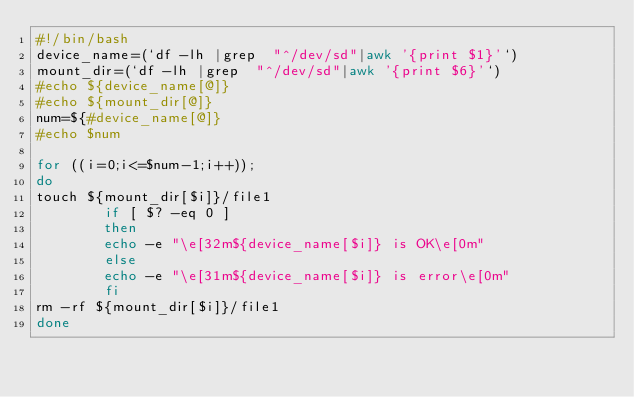Convert code to text. <code><loc_0><loc_0><loc_500><loc_500><_Bash_>#!/bin/bash
device_name=(`df -lh |grep  "^/dev/sd"|awk '{print $1}'`)
mount_dir=(`df -lh |grep  "^/dev/sd"|awk '{print $6}'`)
#echo ${device_name[@]}
#echo ${mount_dir[@]}
num=${#device_name[@]}
#echo $num

for ((i=0;i<=$num-1;i++));
do
touch ${mount_dir[$i]}/file1
        if [ $? -eq 0 ]
        then
        echo -e "\e[32m${device_name[$i]} is OK\e[0m"
        else
        echo -e "\e[31m${device_name[$i]} is error\e[0m"
        fi
rm -rf ${mount_dir[$i]}/file1
done
</code> 